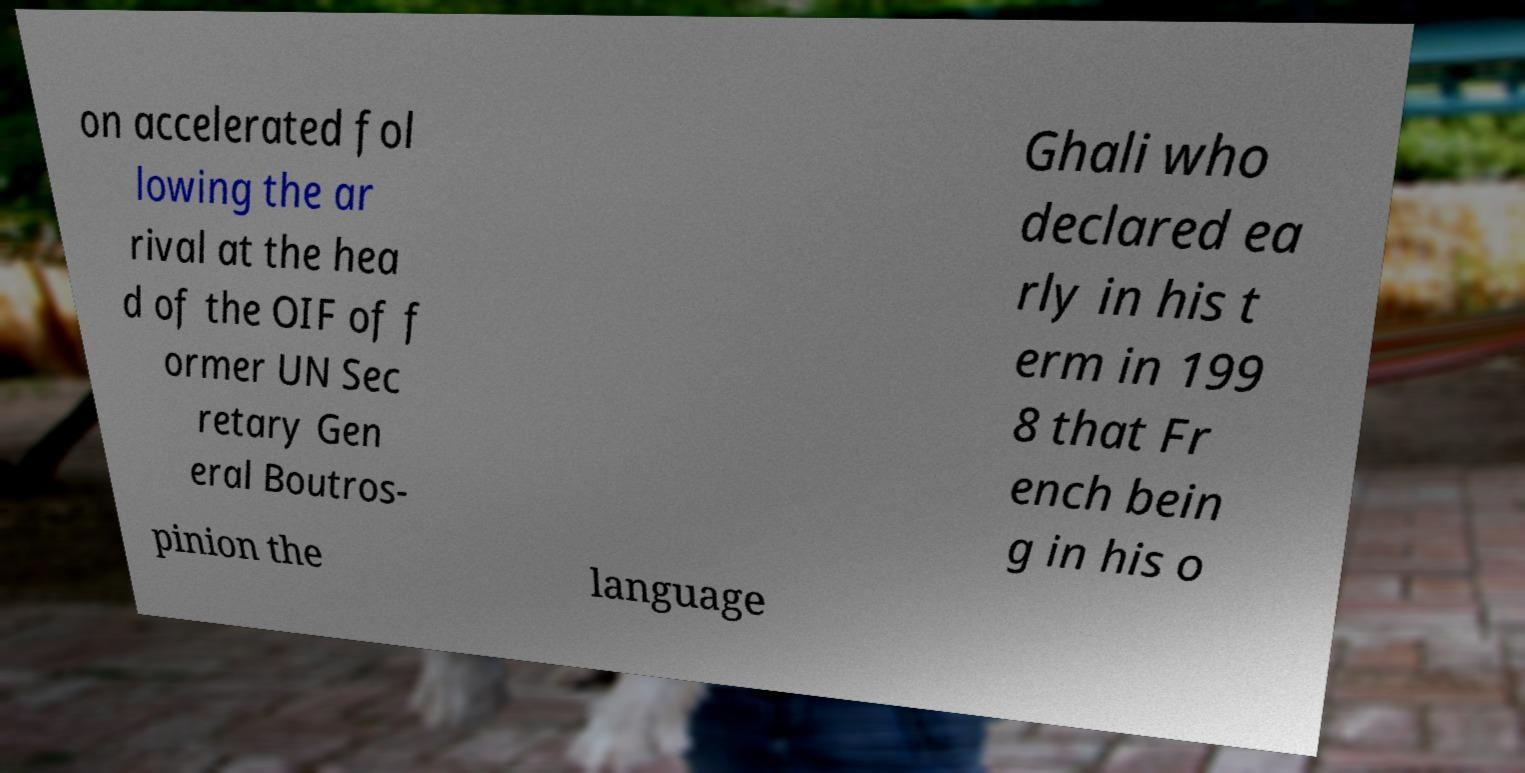Please read and relay the text visible in this image. What does it say? on accelerated fol lowing the ar rival at the hea d of the OIF of f ormer UN Sec retary Gen eral Boutros- Ghali who declared ea rly in his t erm in 199 8 that Fr ench bein g in his o pinion the language 